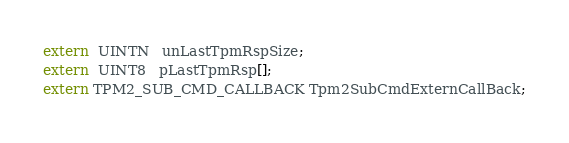Convert code to text. <code><loc_0><loc_0><loc_500><loc_500><_C_>extern  UINTN   unLastTpmRspSize;
extern  UINT8   pLastTpmRsp[];
extern TPM2_SUB_CMD_CALLBACK Tpm2SubCmdExternCallBack;
</code> 